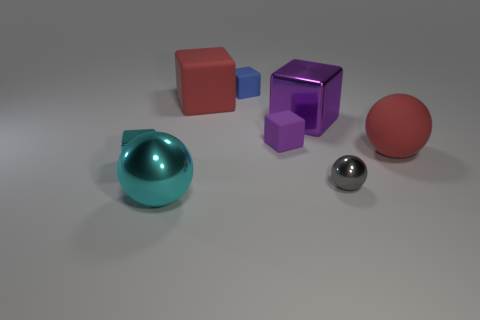Subtract 1 blocks. How many blocks are left? 4 Subtract all red cubes. How many cubes are left? 4 Subtract all purple matte cubes. How many cubes are left? 4 Subtract all purple balls. Subtract all purple cubes. How many balls are left? 3 Add 1 gray spheres. How many objects exist? 9 Subtract all cubes. How many objects are left? 3 Subtract 0 brown cubes. How many objects are left? 8 Subtract all blue things. Subtract all large blue matte cubes. How many objects are left? 7 Add 4 purple objects. How many purple objects are left? 6 Add 1 small green rubber spheres. How many small green rubber spheres exist? 1 